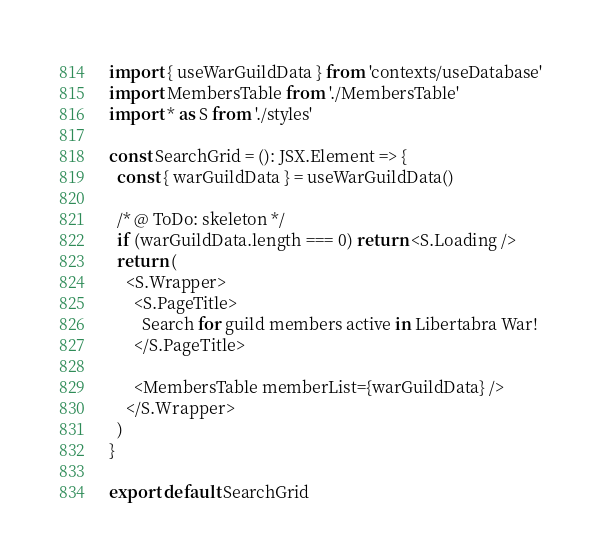Convert code to text. <code><loc_0><loc_0><loc_500><loc_500><_TypeScript_>import { useWarGuildData } from 'contexts/useDatabase'
import MembersTable from './MembersTable'
import * as S from './styles'

const SearchGrid = (): JSX.Element => {
  const { warGuildData } = useWarGuildData()

  /* @ ToDo: skeleton */
  if (warGuildData.length === 0) return <S.Loading />
  return (
    <S.Wrapper>
      <S.PageTitle>
        Search for guild members active in Libertabra War!
      </S.PageTitle>

      <MembersTable memberList={warGuildData} />
    </S.Wrapper>
  )
}

export default SearchGrid
</code> 